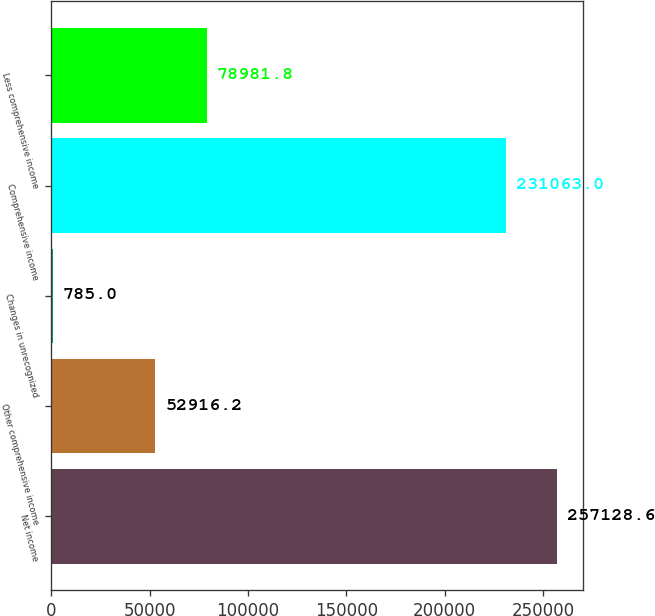Convert chart. <chart><loc_0><loc_0><loc_500><loc_500><bar_chart><fcel>Net income<fcel>Other comprehensive income<fcel>Changes in unrecognized<fcel>Comprehensive income<fcel>Less comprehensive income<nl><fcel>257129<fcel>52916.2<fcel>785<fcel>231063<fcel>78981.8<nl></chart> 